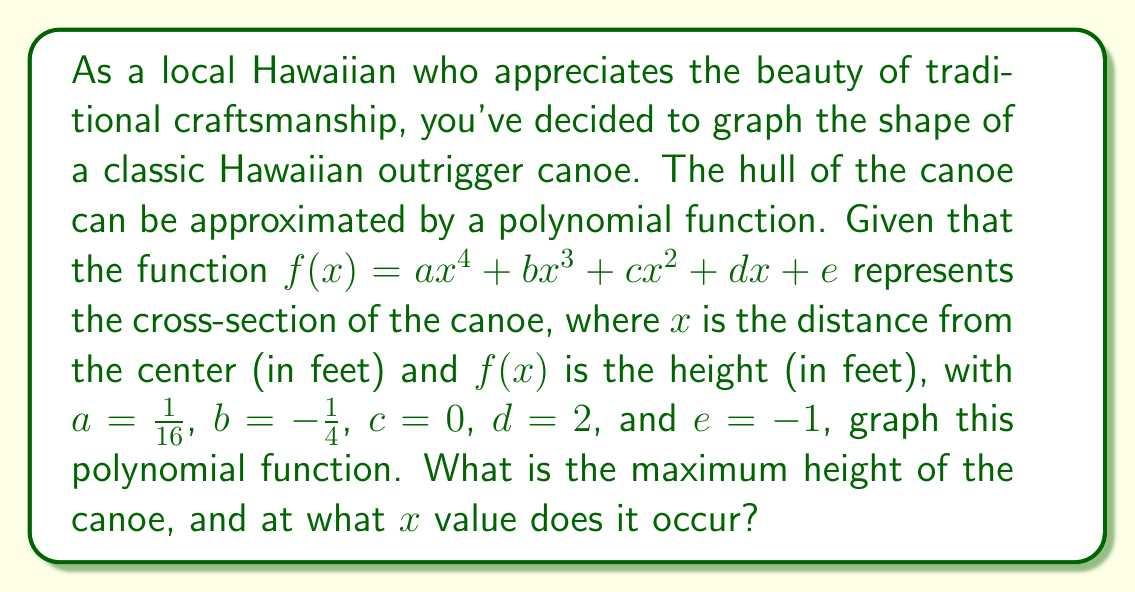Provide a solution to this math problem. To solve this problem, we'll follow these steps:

1) First, let's write out our polynomial function with the given coefficients:

   $$f(x) = \frac{1}{16}x^4 - \frac{1}{4}x^3 + 2x - 1$$

2) To find the maximum height, we need to find the local maximum of this function. This occurs where the derivative $f'(x) = 0$.

3) Let's calculate the derivative:

   $$f'(x) = \frac{1}{4}x^3 - \frac{3}{4}x^2 + 2$$

4) Set this equal to zero and solve:

   $$\frac{1}{4}x^3 - \frac{3}{4}x^2 + 2 = 0$$

5) This is a cubic equation. It's not easily solvable by factoring, so we can use a graphing calculator or computer algebra system to find the roots. The solutions are approximately:

   $x \approx -1.32$, $x \approx 1.32$, and $x \approx 2$

6) Since we're looking at a canoe shape, we're interested in the positive x-value that's less than 2 (as the canoe is symmetrical and 2 feet is likely the half-width). So, we'll use $x \approx 1.32$.

7) To find the maximum height, we plug this x-value back into our original function:

   $$f(1.32) \approx \frac{1}{16}(1.32)^4 - \frac{1}{4}(1.32)^3 + 2(1.32) - 1 \approx 1.32$$

8) To graph the function, we can use a graphing calculator or plotting software. The graph will show a symmetrical shape resembling a canoe cross-section.

[asy]
import graph;
size(200,150);
real f(real x) {return (1/16)*x^4 - (1/4)*x^3 + 2*x - 1;}
draw(graph(f,-2,2));
draw((-2,0)--(2,0),arrow=Arrow(TeXHead));
draw((0,-1.5)--(0,1.5),arrow=Arrow(TeXHead));
label("x",(2,0),E);
label("y",(0,1.5),N);
dot((1.32,f(1.32)),red);
label("(1.32, 1.32)",(1.32,f(1.32)),NE);
[/asy]
Answer: The maximum height of the canoe is approximately 1.32 feet, occurring at x ≈ 1.32 feet from the center. 